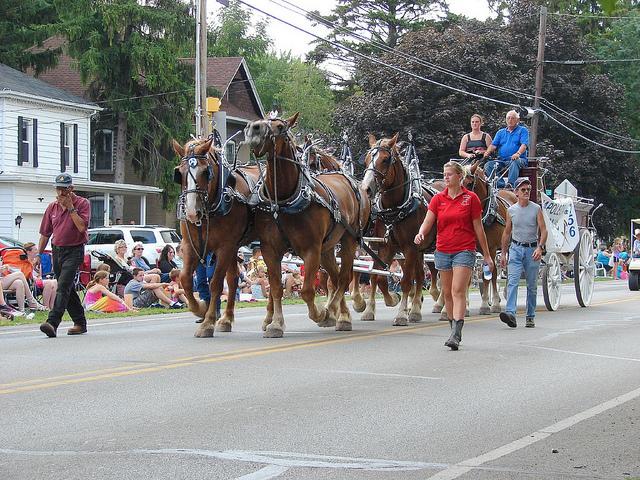Are they marching?
Write a very short answer. Yes. What color are the horses?
Short answer required. Brown. How many horses are seen?
Short answer required. 4. 